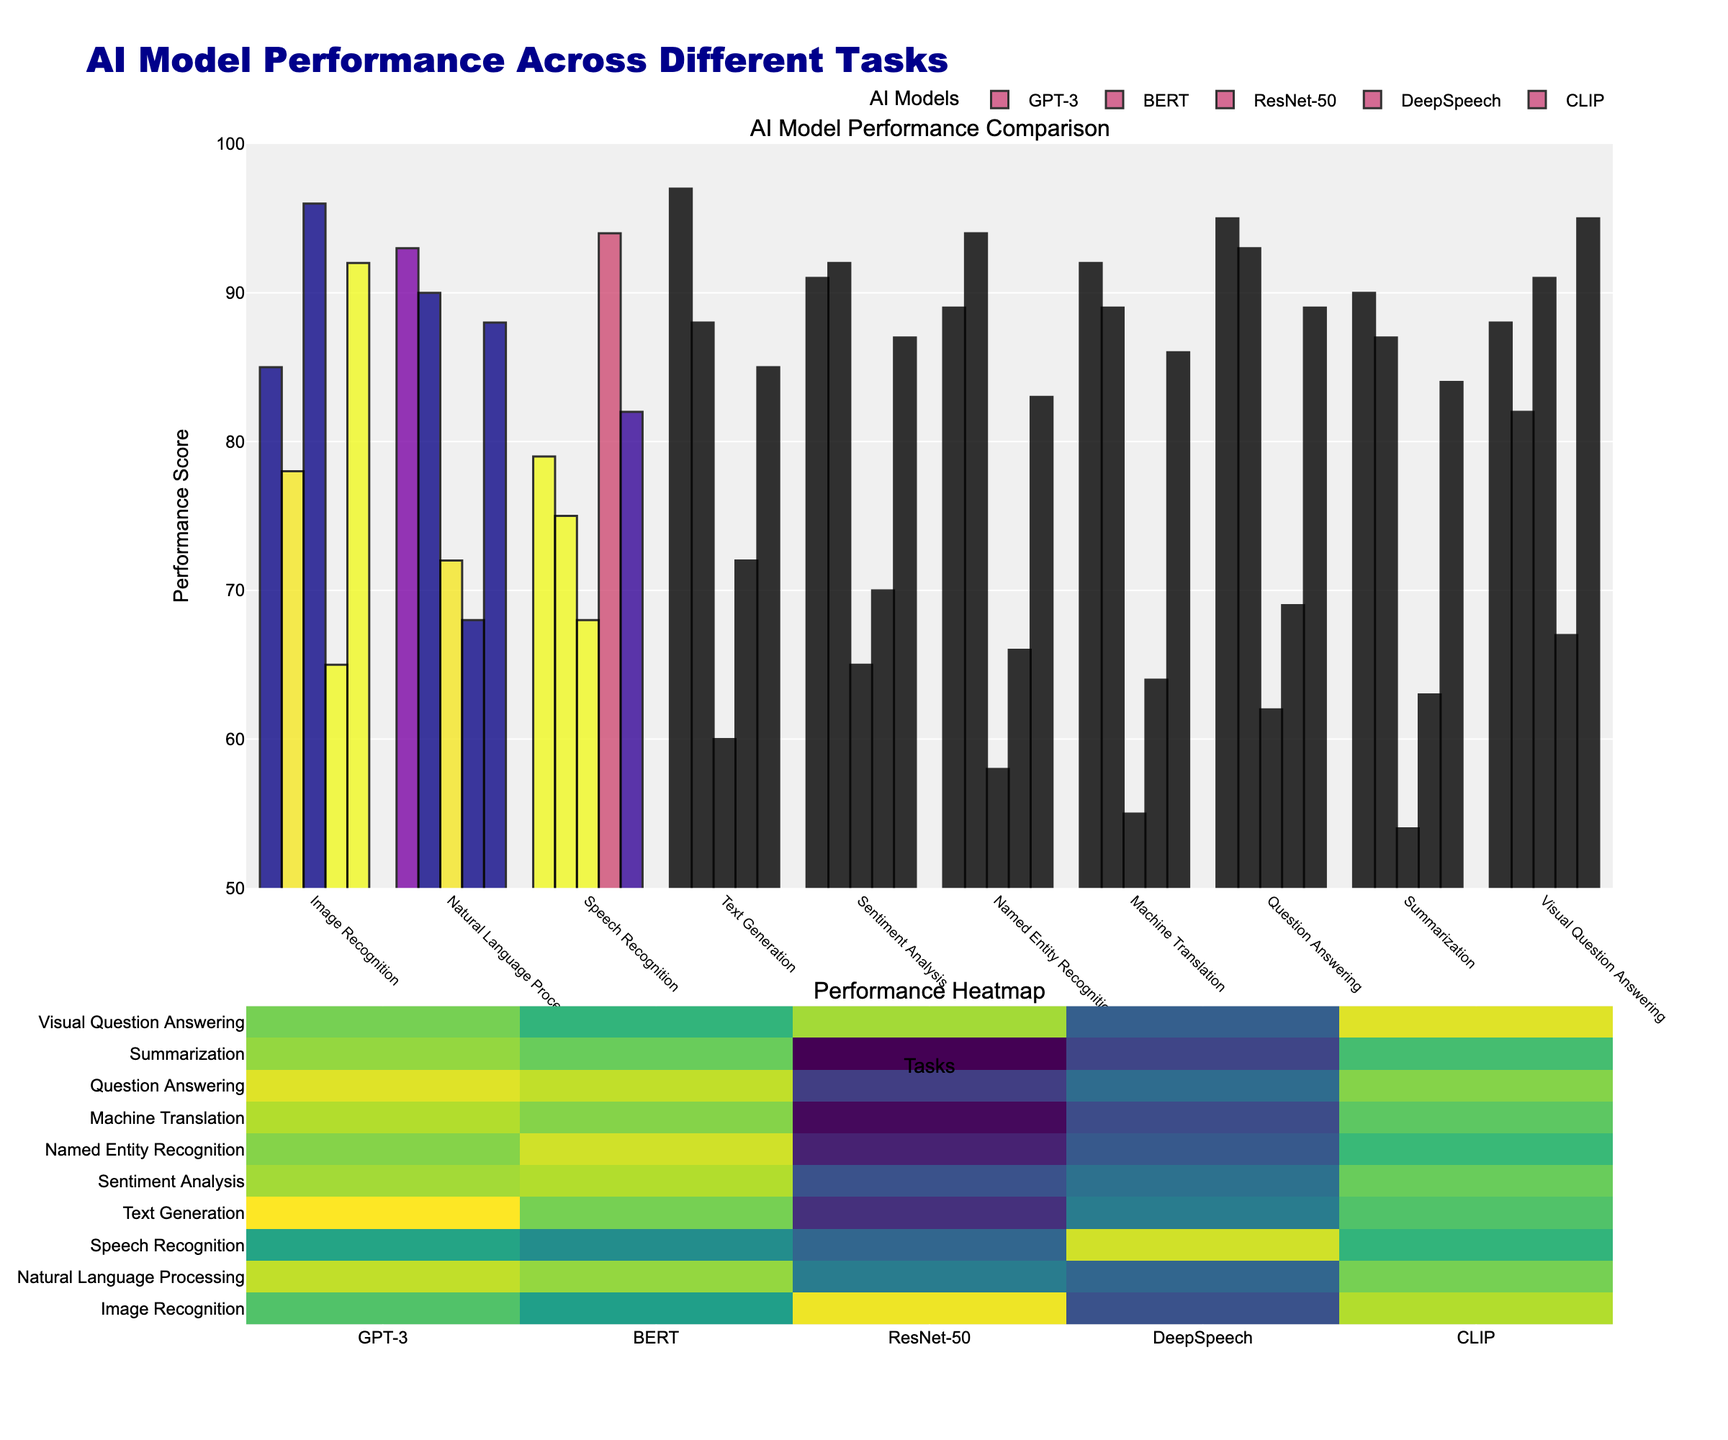What is the highest performance score in Image Recognition, and which model achieves it? First, locate the task "Image Recognition". Then, compare the scores of all models for this task. The highest score is achieved by ResNet-50 with a score of 96
Answer: ResNet-50 with a score of 96 Which model has the lowest performance in Speech Recognition? Identify the scores for "Speech Recognition" across all models. The lowest performance is by ResNet-50 with a score of 68
Answer: ResNet-50 with a score of 68 Which model in the Visual Question Answering task has the largest performance difference when compared to the performance of GPT-3 in the same task? Look at the scores for "Visual Question Answering". Calculate the difference for each model's score compared to GPT-3 (88). CLIP has the largest difference, with 95 - 88, a difference of 7
Answer: CLIP with a difference of 7 What is the average performance score of BERT for all listed tasks? Sum the performance scores of BERT across the 10 tasks and divide by 10 (90 + 92 + 75 + 88 + 92 + 94 + 89 + 93 + 87 + 82 = 882; 882 / 10 = 88.2)
Answer: 88.2 Among the models in Natural Language Processing, which two have the closest performance scores and what is the difference? Check the performance scores for "Natural Language Processing". The closest scores are GPT-3 (93) and BERT (90), with a difference of 3
Answer: GPT-3 and BERT with a difference of 3 In which tasks does DeepSpeech outperform BERT? List the tasks. Compare DeepSpeech to BERT in each task. DeepSpeech outperforms BERT in "Speech Recognition" (94 vs 75)
Answer: Speech Recognition Which task has the highest overall average performance score across all models? Calculate the average score for each task: Sum of scores for each task and then divide by 5. The highest overall average is in "Natural Language Processing" [(93 + 90 + 72 + 68 + 88) / 5 = 82.2]
Answer: Natural Language Processing Which model performs consistently above 80 across all tasks? Check each model's scores to see if any model scores above 80 for each task. GPT-3 is the only model scoring above 80 for all tasks
Answer: GPT-3 What is the median score of GPT-3 across all the tasks? List all GPT-3 scores (85, 93, 79, 97, 91, 89, 92, 95, 90, 88) and find the middle value in the ordered set. The median score is (89 + 90) / 2 = 89.5
Answer: 89.5 By how much does the performance of CLIP in Image Recognition exceed BERT's performance in the same task? Compare the scores of CLIP and BERT in "Image Recognition". CLIP (92) exceeds BERT (78) by 92 - 78 = 14 points
Answer: 14 points 